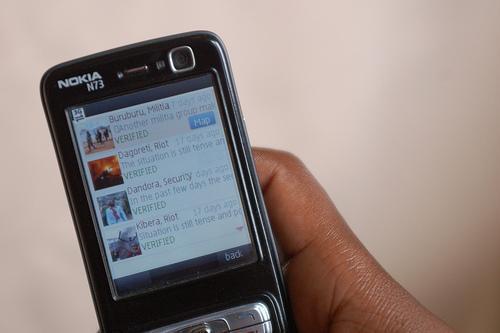How many selections on the phone screen are highlighted?
Give a very brief answer. 1. 